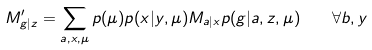<formula> <loc_0><loc_0><loc_500><loc_500>M ^ { \prime } _ { g | z } = \sum _ { a , x , \mu } p ( \mu ) p ( x | y , \mu ) M _ { a | x } p ( g | a , z , \mu ) \quad \forall b , y</formula> 